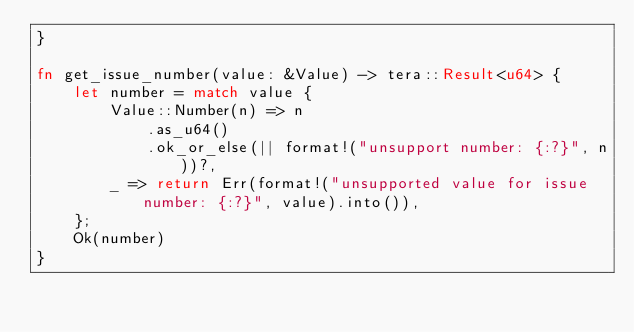Convert code to text. <code><loc_0><loc_0><loc_500><loc_500><_Rust_>}

fn get_issue_number(value: &Value) -> tera::Result<u64> {
    let number = match value {
        Value::Number(n) => n
            .as_u64()
            .ok_or_else(|| format!("unsupport number: {:?}", n))?,
        _ => return Err(format!("unsupported value for issue number: {:?}", value).into()),
    };
    Ok(number)
}
</code> 